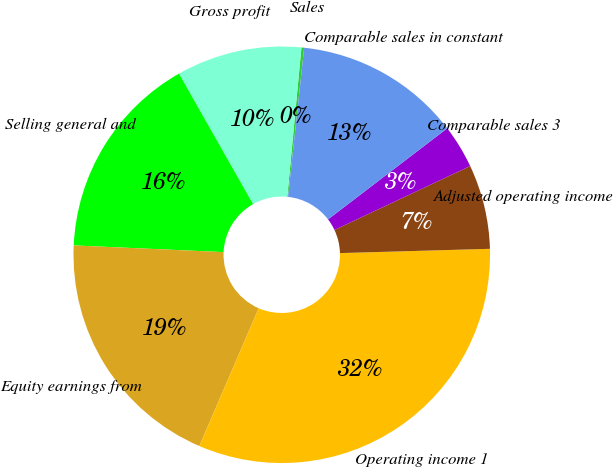Convert chart. <chart><loc_0><loc_0><loc_500><loc_500><pie_chart><fcel>Sales<fcel>Gross profit<fcel>Selling general and<fcel>Equity earnings from<fcel>Operating income 1<fcel>Adjusted operating income<fcel>Comparable sales 3<fcel>Comparable sales in constant<nl><fcel>0.21%<fcel>9.72%<fcel>16.07%<fcel>19.24%<fcel>31.93%<fcel>6.55%<fcel>3.38%<fcel>12.9%<nl></chart> 